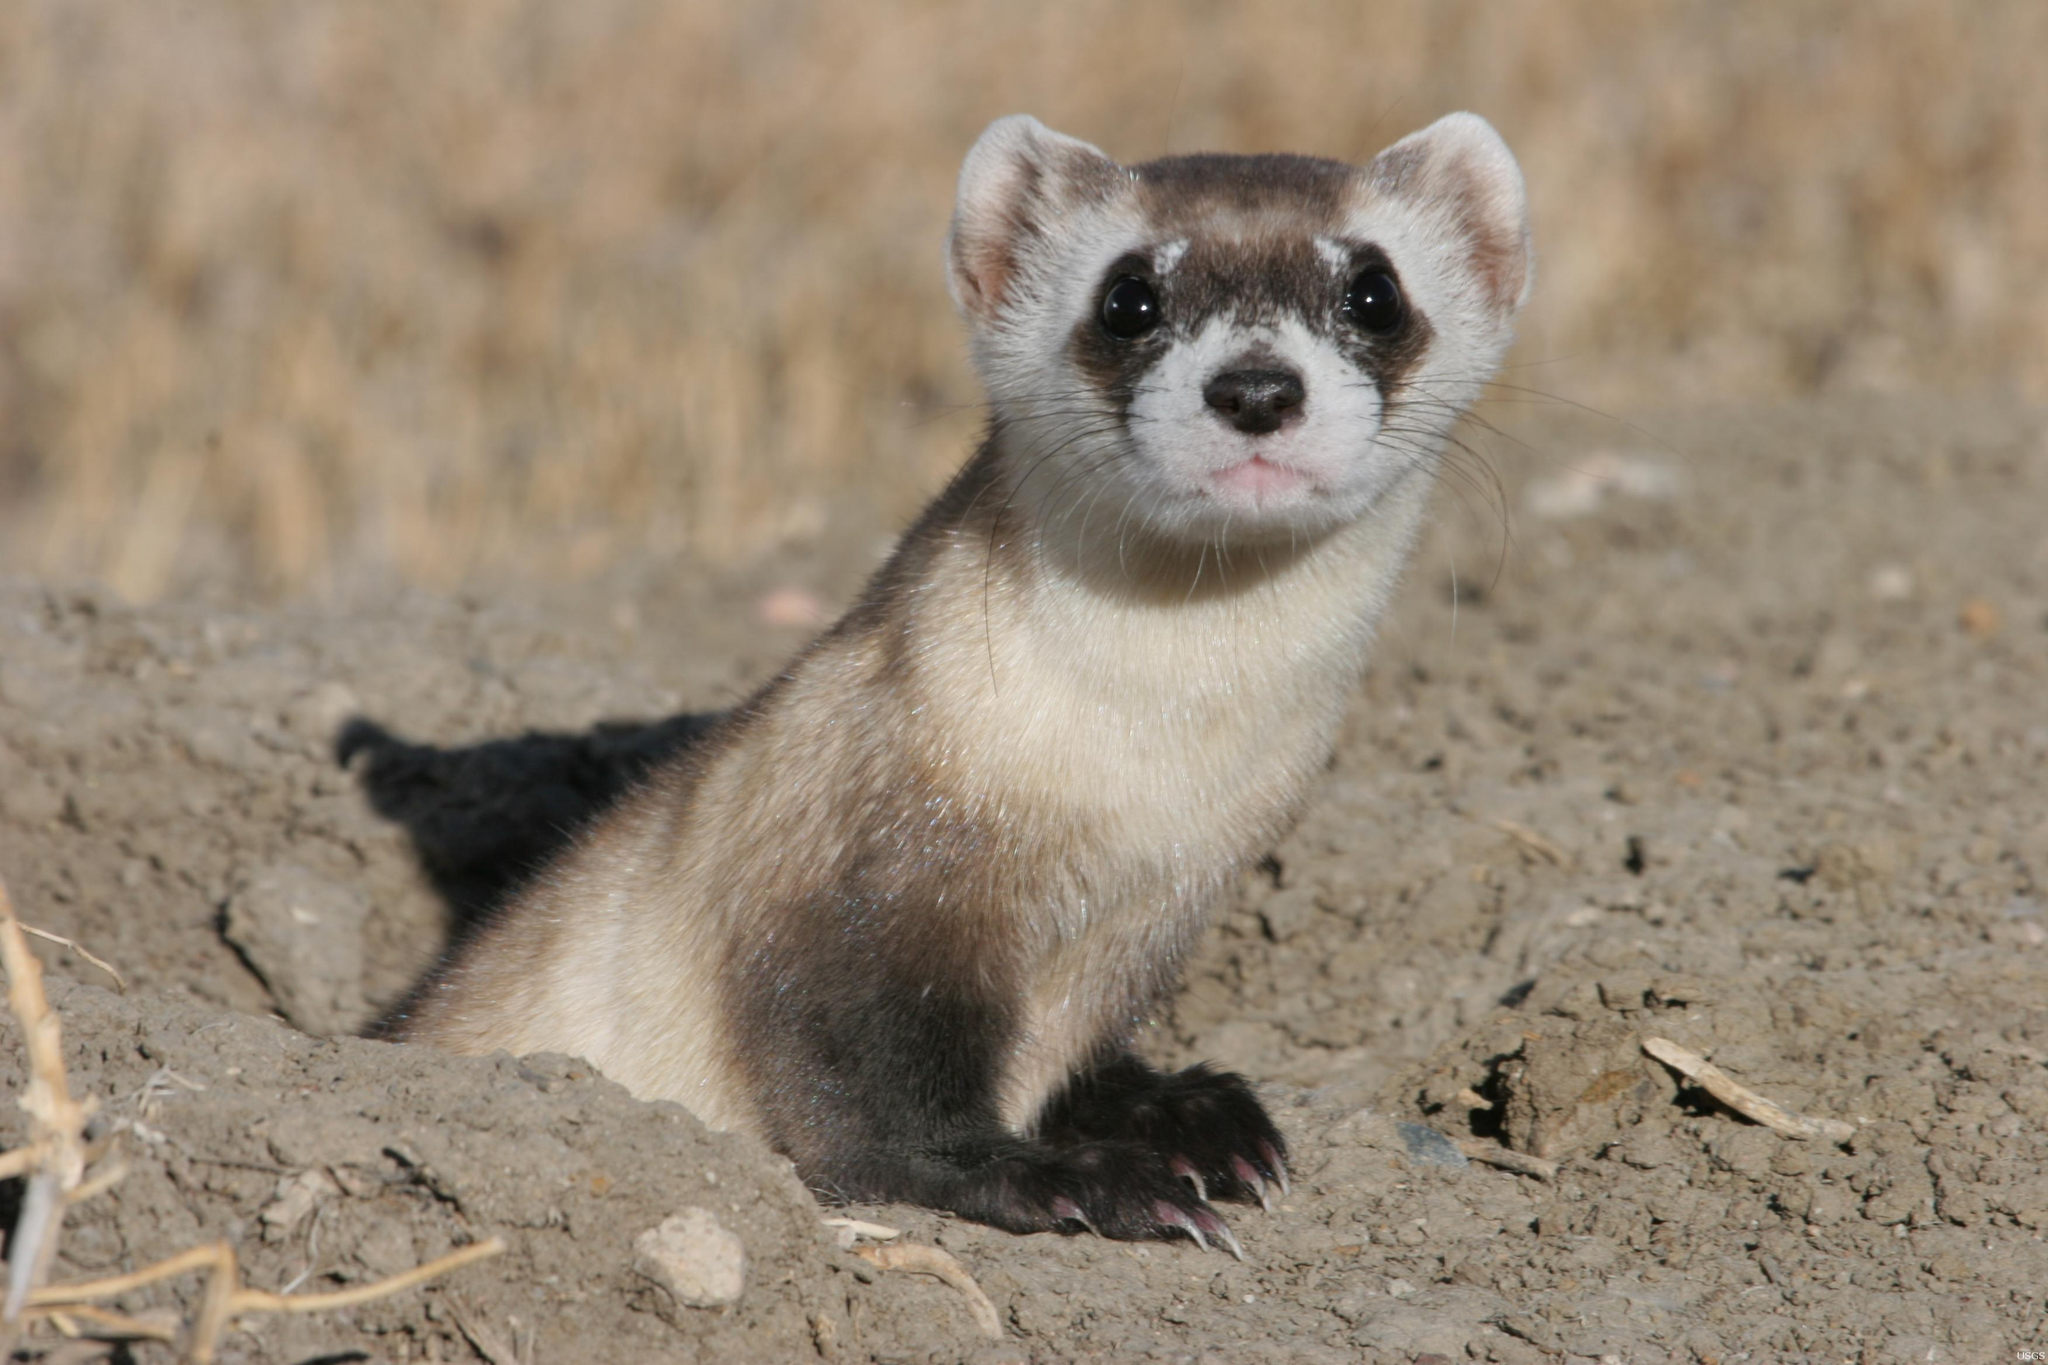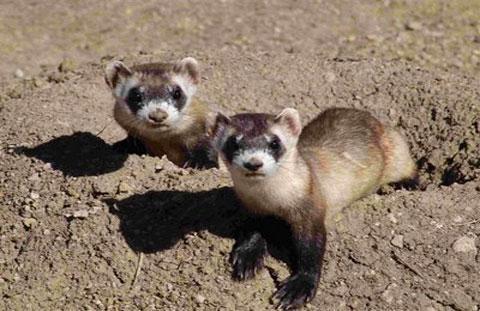The first image is the image on the left, the second image is the image on the right. For the images displayed, is the sentence "Prairie dogs pose together in the image on the right." factually correct? Answer yes or no. Yes. 